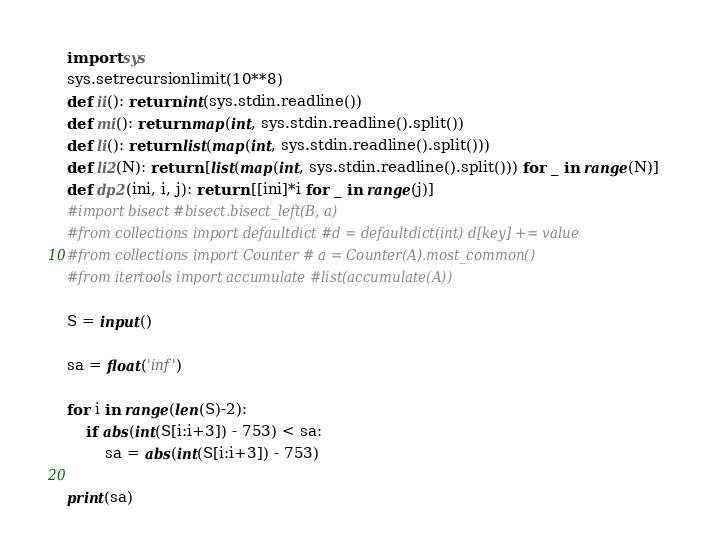<code> <loc_0><loc_0><loc_500><loc_500><_Python_>import sys
sys.setrecursionlimit(10**8)
def ii(): return int(sys.stdin.readline())
def mi(): return map(int, sys.stdin.readline().split())
def li(): return list(map(int, sys.stdin.readline().split()))
def li2(N): return [list(map(int, sys.stdin.readline().split())) for _ in range(N)]
def dp2(ini, i, j): return [[ini]*i for _ in range(j)]
#import bisect #bisect.bisect_left(B, a)
#from collections import defaultdict #d = defaultdict(int) d[key] += value
#from collections import Counter # a = Counter(A).most_common()
#from itertools import accumulate #list(accumulate(A))

S = input()

sa = float('inf')

for i in range(len(S)-2):
    if abs(int(S[i:i+3]) - 753) < sa:
        sa = abs(int(S[i:i+3]) - 753)

print(sa)</code> 